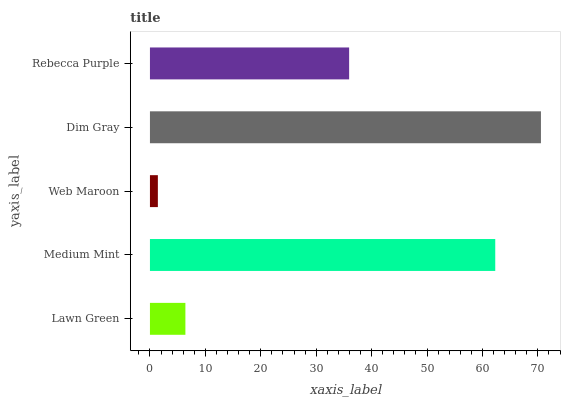Is Web Maroon the minimum?
Answer yes or no. Yes. Is Dim Gray the maximum?
Answer yes or no. Yes. Is Medium Mint the minimum?
Answer yes or no. No. Is Medium Mint the maximum?
Answer yes or no. No. Is Medium Mint greater than Lawn Green?
Answer yes or no. Yes. Is Lawn Green less than Medium Mint?
Answer yes or no. Yes. Is Lawn Green greater than Medium Mint?
Answer yes or no. No. Is Medium Mint less than Lawn Green?
Answer yes or no. No. Is Rebecca Purple the high median?
Answer yes or no. Yes. Is Rebecca Purple the low median?
Answer yes or no. Yes. Is Medium Mint the high median?
Answer yes or no. No. Is Lawn Green the low median?
Answer yes or no. No. 